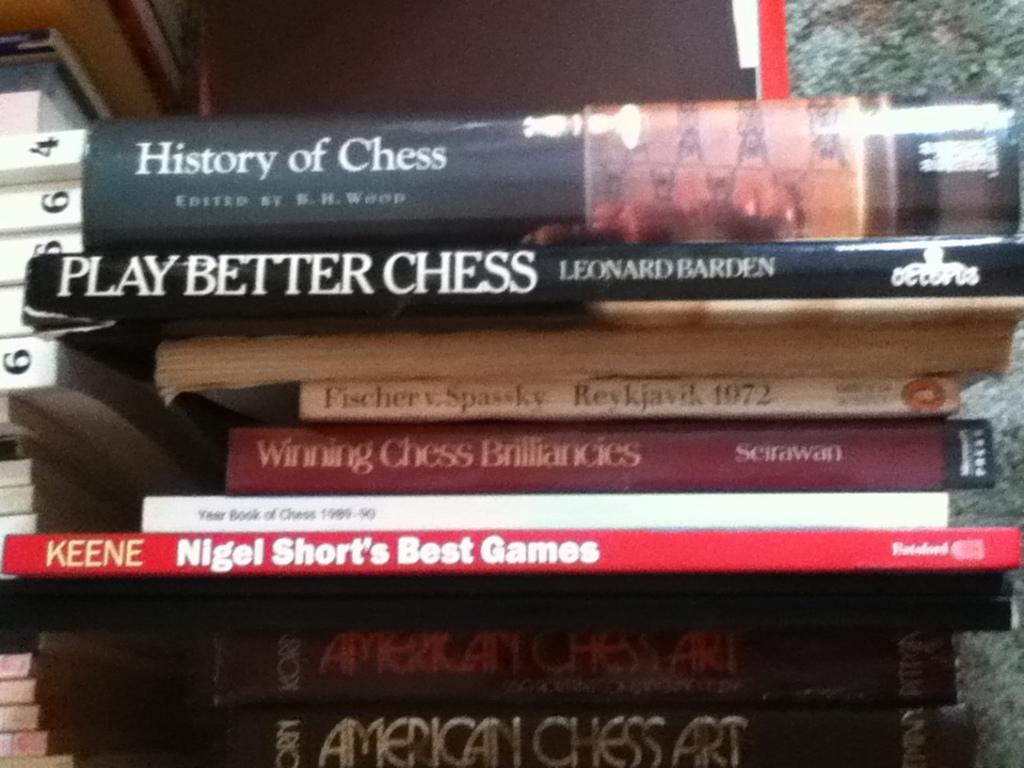What is the title of the book on the top?
Make the answer very short. History of chess. 